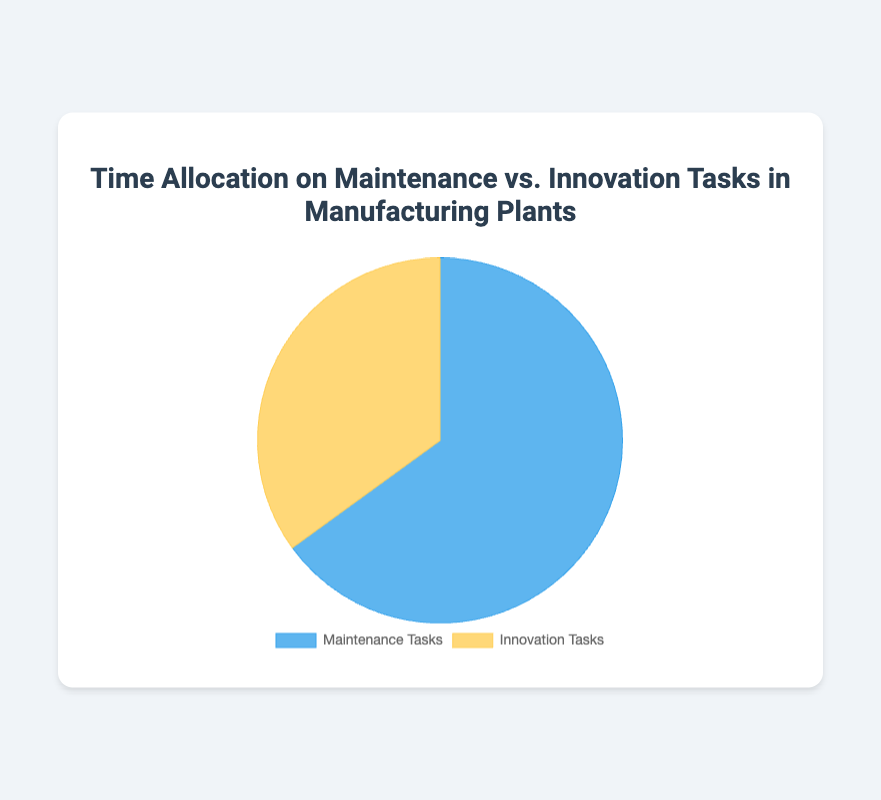What's the percentage of time allocated to Maintenance Tasks? The pie chart shows that 65% of the time is allocated to Maintenance Tasks.
Answer: 65% Which task type has the higher percentage allocation, Maintenance Tasks or Innovation Tasks? By comparing the two slices of the pie chart, Maintenance Tasks have a higher percentage at 65% compared to Innovation Tasks at 35%.
Answer: Maintenance Tasks What is the difference in percentage allocation between Maintenance Tasks and Innovation Tasks? The pie chart shows Maintenance Tasks at 65% and Innovation Tasks at 35%. The difference is 65% - 35% = 30%.
Answer: 30% If the total time is 100 hours, how much time is allocated to Innovation Tasks? Innovation Tasks take up 35% of the total time. If the total time is 100 hours, then 35/100 * 100 hours = 35 hours are allocated to Innovation Tasks.
Answer: 35 hours What is the ratio of time spent on Maintenance Tasks to the time spent on Innovation Tasks? The pie chart shows 65% of time on Maintenance Tasks and 35% on Innovation Tasks. The ratio is 65:35, which simplifies to 13:7.
Answer: 13:7 How much more time is spent on Maintenance Tasks compared to Innovation Tasks in percentage terms? Maintenance Tasks are 65% and Innovation Tasks are 35%. The difference is 65% - 35% = 30%. The Maintenance Tasks have 30% more time allocation than Innovation Tasks.
Answer: 30% What are the colors used to represent Maintenance and Innovation Tasks in the pie chart? The pie chart shows Maintenance Tasks in blue and Innovation Tasks in yellow.
Answer: Blue (Maintenance Tasks), Yellow (Innovation Tasks) If you reallocated 10% of the time from Maintenance to Innovation, what would the new percentages be for each task type? Initially, Maintenance is 65% and Innovation is 35%. Reallocating 10% from Maintenance to Innovation would result in 65% - 10% = 55% for Maintenance and 35% + 10% = 45% for Innovation.
Answer: 55% (Maintenance), 45% (Innovation) What percentage of the chart is dedicated to Maintenance Tasks, and how can you visualize which section it represents? The chart shows that 65% is dedicated to Maintenance Tasks. Visually, this is the larger blue section of the pie chart.
Answer: 65%, blue section If the total operational budget is divided according to the time allocation percentages, how would the budget be split between Maintenance and Innovation Tasks? If the total budget is divided as per the chart, Maintenance Tasks would receive 65% of the budget and Innovation Tasks 35%. For example, if the budget is $1,000,000, Maintenance gets $650,000 (65%) and Innovation gets $350,000 (35%).
Answer: $650,000 (Maintenance), $350,000 (Innovation) 